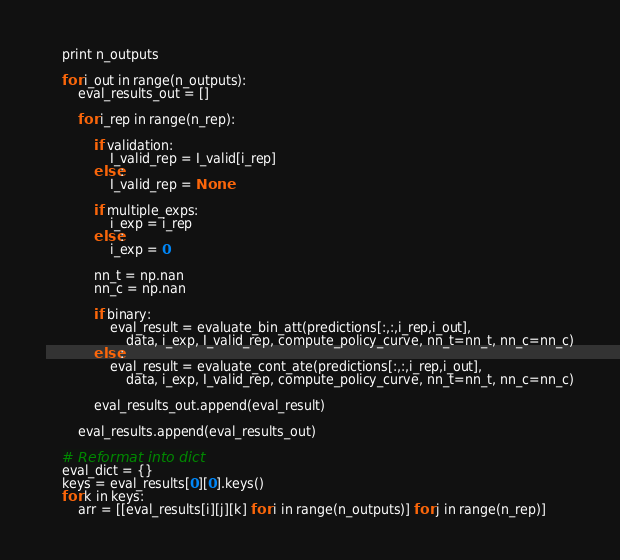<code> <loc_0><loc_0><loc_500><loc_500><_Python_>    print n_outputs

    for i_out in range(n_outputs):
        eval_results_out = []

        for i_rep in range(n_rep):

            if validation:
                I_valid_rep = I_valid[i_rep]
            else:
                I_valid_rep = None

            if multiple_exps:
                i_exp = i_rep
            else:
                i_exp = 0

            nn_t = np.nan
            nn_c = np.nan

            if binary:
                eval_result = evaluate_bin_att(predictions[:,:,i_rep,i_out],
                    data, i_exp, I_valid_rep, compute_policy_curve, nn_t=nn_t, nn_c=nn_c)
            else:
                eval_result = evaluate_cont_ate(predictions[:,:,i_rep,i_out],
                    data, i_exp, I_valid_rep, compute_policy_curve, nn_t=nn_t, nn_c=nn_c)

            eval_results_out.append(eval_result)

        eval_results.append(eval_results_out)

    # Reformat into dict
    eval_dict = {}
    keys = eval_results[0][0].keys()
    for k in keys:
        arr = [[eval_results[i][j][k] for i in range(n_outputs)] for j in range(n_rep)]</code> 